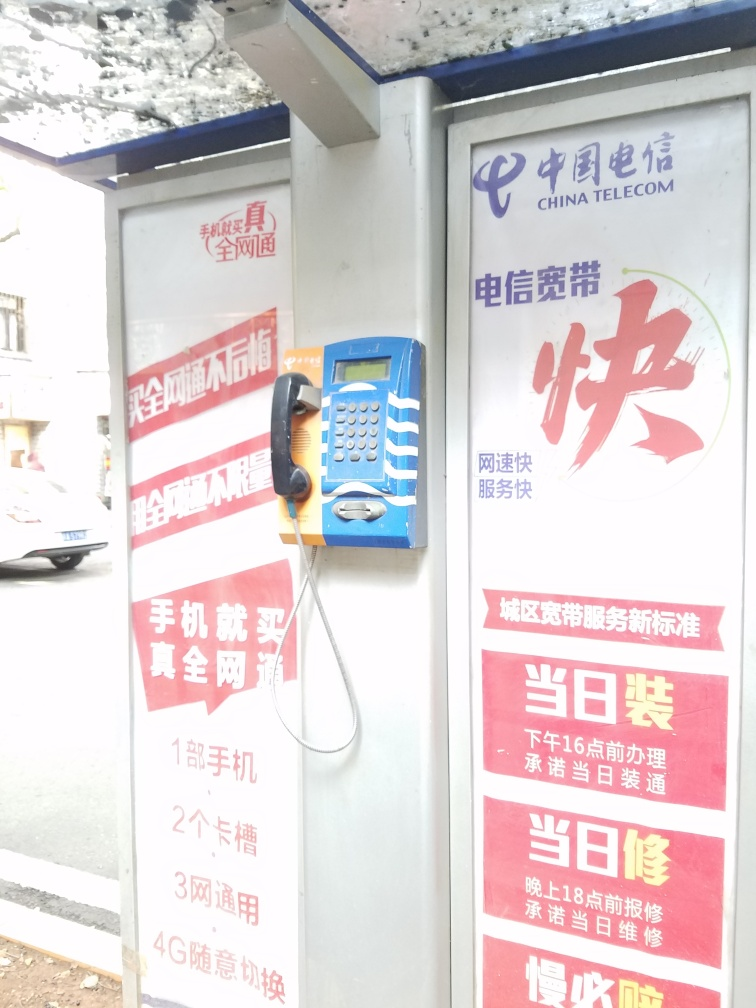Is the main subject in the image very blurry? The main subject, a public telephone, appears moderately blurry, with some of its features, such as the keypad and handset, lacking sharpness. The surrounding posters and background elements are also affected by this lack of clarity, suggesting the photo was taken in motion or without proper focus. 